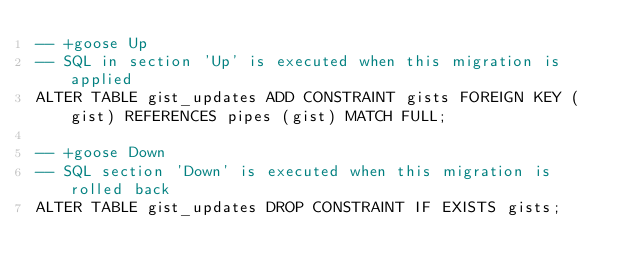<code> <loc_0><loc_0><loc_500><loc_500><_SQL_>-- +goose Up
-- SQL in section 'Up' is executed when this migration is applied
ALTER TABLE gist_updates ADD CONSTRAINT gists FOREIGN KEY (gist) REFERENCES pipes (gist) MATCH FULL;

-- +goose Down
-- SQL section 'Down' is executed when this migration is rolled back
ALTER TABLE gist_updates DROP CONSTRAINT IF EXISTS gists;
</code> 